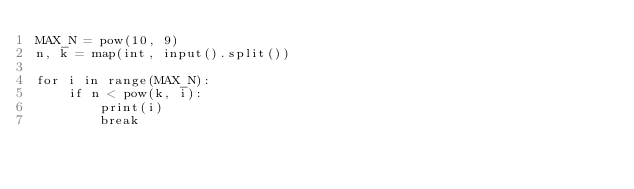Convert code to text. <code><loc_0><loc_0><loc_500><loc_500><_Python_>MAX_N = pow(10, 9)
n, k = map(int, input().split())

for i in range(MAX_N):
    if n < pow(k, i):
        print(i)
        break
</code> 